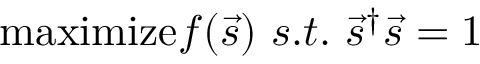Convert formula to latex. <formula><loc_0><loc_0><loc_500><loc_500>\max i m i z e f ( \vec { s } ) \ s . t . \ \vec { s } ^ { \dagger } \vec { s } = 1</formula> 